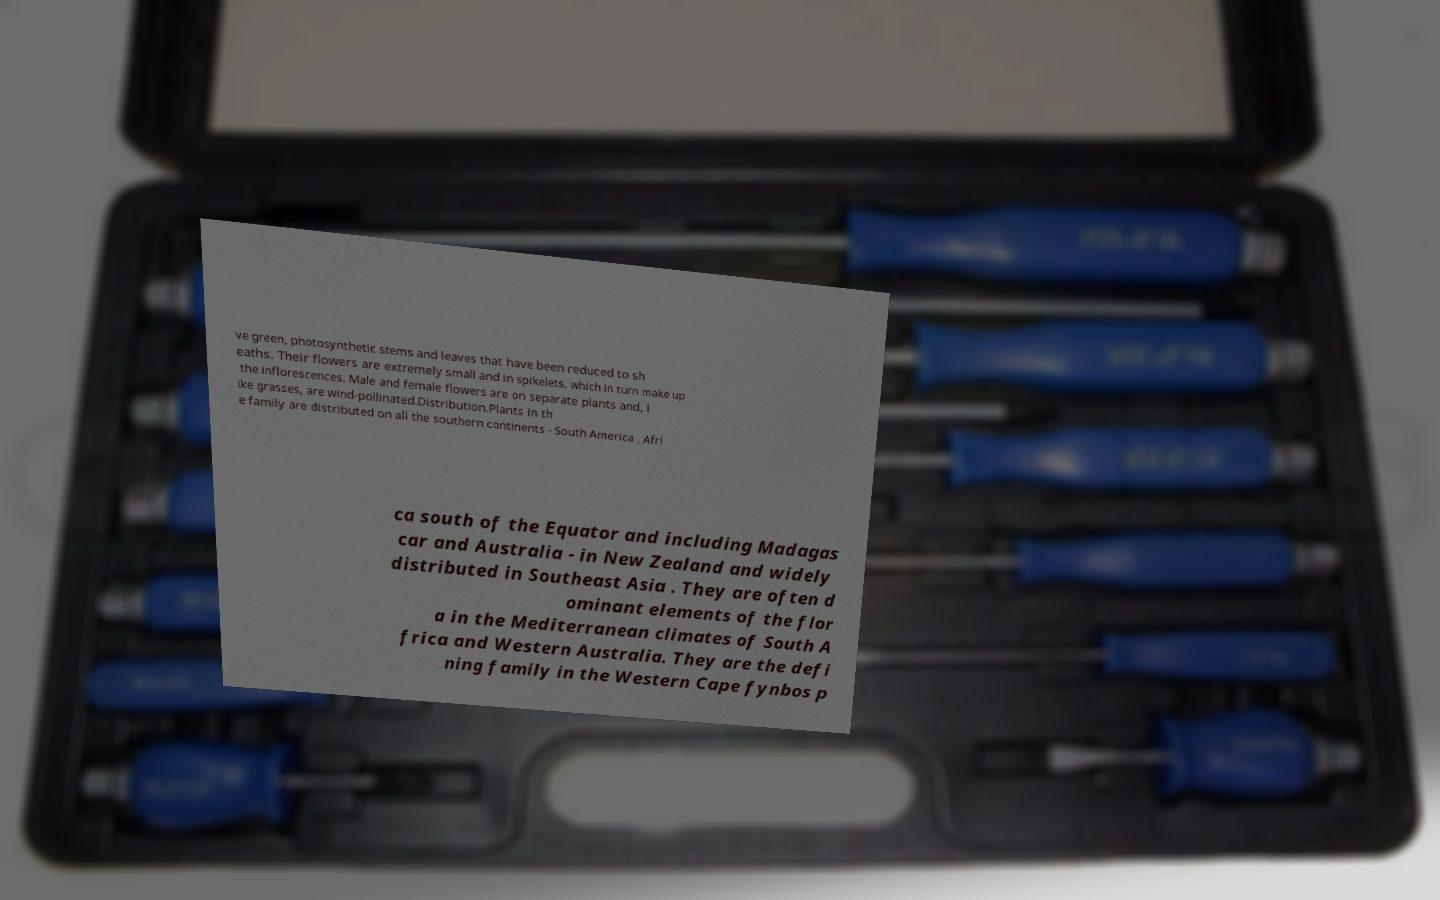What messages or text are displayed in this image? I need them in a readable, typed format. ve green, photosynthetic stems and leaves that have been reduced to sh eaths. Their flowers are extremely small and in spikelets, which in turn make up the inflorescences. Male and female flowers are on separate plants and, l ike grasses, are wind-pollinated.Distribution.Plants in th e family are distributed on all the southern continents - South America , Afri ca south of the Equator and including Madagas car and Australia - in New Zealand and widely distributed in Southeast Asia . They are often d ominant elements of the flor a in the Mediterranean climates of South A frica and Western Australia. They are the defi ning family in the Western Cape fynbos p 